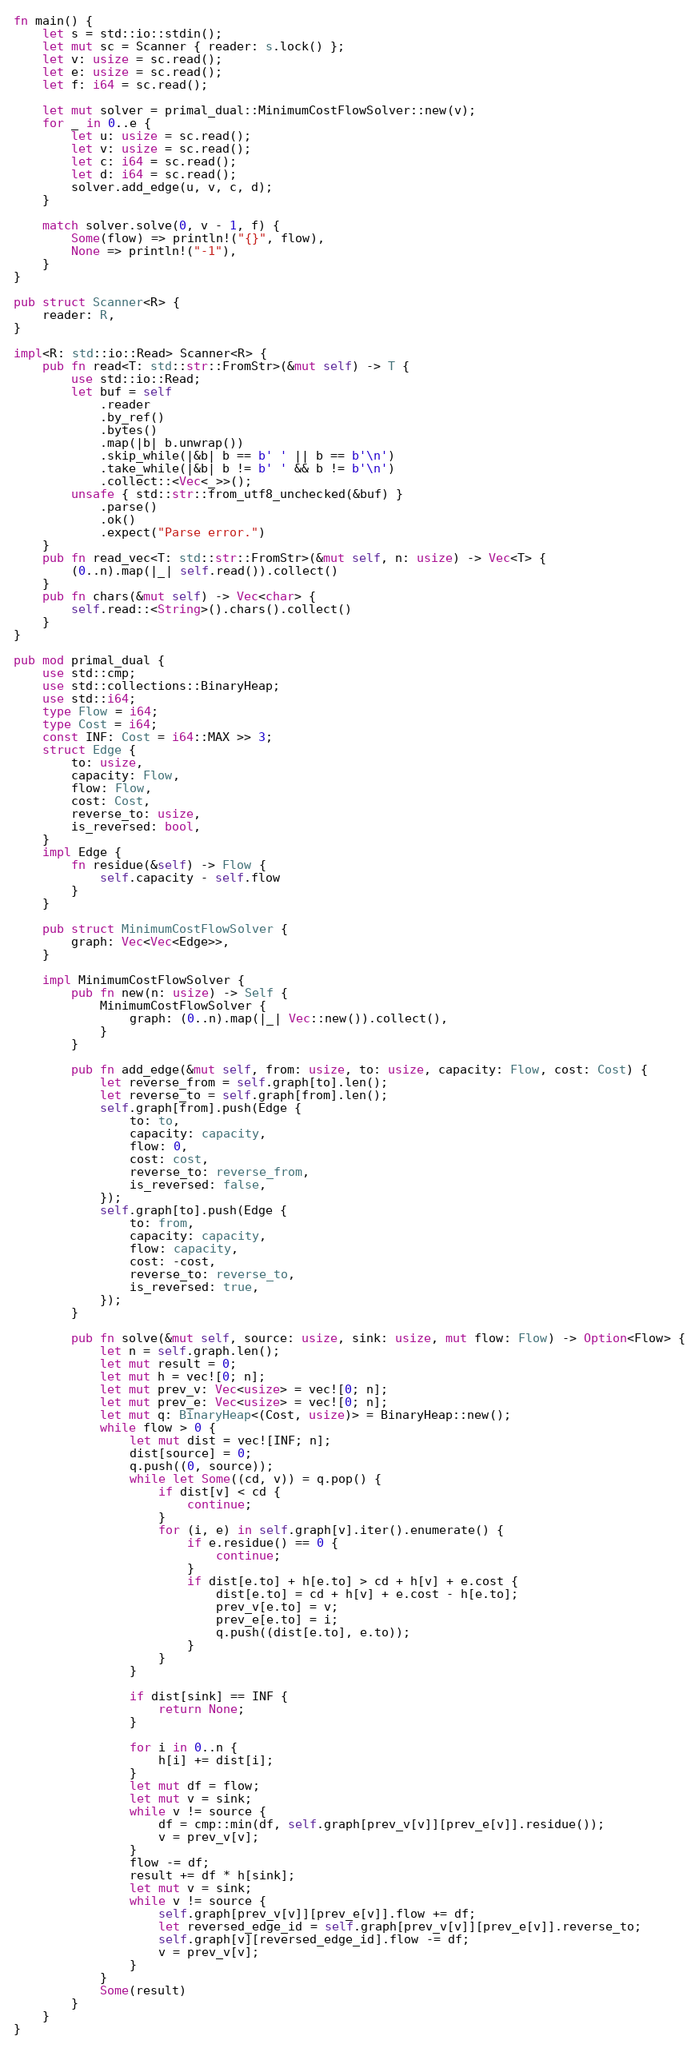<code> <loc_0><loc_0><loc_500><loc_500><_Rust_>fn main() {
    let s = std::io::stdin();
    let mut sc = Scanner { reader: s.lock() };
    let v: usize = sc.read();
    let e: usize = sc.read();
    let f: i64 = sc.read();

    let mut solver = primal_dual::MinimumCostFlowSolver::new(v);
    for _ in 0..e {
        let u: usize = sc.read();
        let v: usize = sc.read();
        let c: i64 = sc.read();
        let d: i64 = sc.read();
        solver.add_edge(u, v, c, d);
    }

    match solver.solve(0, v - 1, f) {
        Some(flow) => println!("{}", flow),
        None => println!("-1"),
    }
}

pub struct Scanner<R> {
    reader: R,
}

impl<R: std::io::Read> Scanner<R> {
    pub fn read<T: std::str::FromStr>(&mut self) -> T {
        use std::io::Read;
        let buf = self
            .reader
            .by_ref()
            .bytes()
            .map(|b| b.unwrap())
            .skip_while(|&b| b == b' ' || b == b'\n')
            .take_while(|&b| b != b' ' && b != b'\n')
            .collect::<Vec<_>>();
        unsafe { std::str::from_utf8_unchecked(&buf) }
            .parse()
            .ok()
            .expect("Parse error.")
    }
    pub fn read_vec<T: std::str::FromStr>(&mut self, n: usize) -> Vec<T> {
        (0..n).map(|_| self.read()).collect()
    }
    pub fn chars(&mut self) -> Vec<char> {
        self.read::<String>().chars().collect()
    }
}

pub mod primal_dual {
    use std::cmp;
    use std::collections::BinaryHeap;
    use std::i64;
    type Flow = i64;
    type Cost = i64;
    const INF: Cost = i64::MAX >> 3;
    struct Edge {
        to: usize,
        capacity: Flow,
        flow: Flow,
        cost: Cost,
        reverse_to: usize,
        is_reversed: bool,
    }
    impl Edge {
        fn residue(&self) -> Flow {
            self.capacity - self.flow
        }
    }

    pub struct MinimumCostFlowSolver {
        graph: Vec<Vec<Edge>>,
    }

    impl MinimumCostFlowSolver {
        pub fn new(n: usize) -> Self {
            MinimumCostFlowSolver {
                graph: (0..n).map(|_| Vec::new()).collect(),
            }
        }

        pub fn add_edge(&mut self, from: usize, to: usize, capacity: Flow, cost: Cost) {
            let reverse_from = self.graph[to].len();
            let reverse_to = self.graph[from].len();
            self.graph[from].push(Edge {
                to: to,
                capacity: capacity,
                flow: 0,
                cost: cost,
                reverse_to: reverse_from,
                is_reversed: false,
            });
            self.graph[to].push(Edge {
                to: from,
                capacity: capacity,
                flow: capacity,
                cost: -cost,
                reverse_to: reverse_to,
                is_reversed: true,
            });
        }

        pub fn solve(&mut self, source: usize, sink: usize, mut flow: Flow) -> Option<Flow> {
            let n = self.graph.len();
            let mut result = 0;
            let mut h = vec![0; n];
            let mut prev_v: Vec<usize> = vec![0; n];
            let mut prev_e: Vec<usize> = vec![0; n];
            let mut q: BinaryHeap<(Cost, usize)> = BinaryHeap::new();
            while flow > 0 {
                let mut dist = vec![INF; n];
                dist[source] = 0;
                q.push((0, source));
                while let Some((cd, v)) = q.pop() {
                    if dist[v] < cd {
                        continue;
                    }
                    for (i, e) in self.graph[v].iter().enumerate() {
                        if e.residue() == 0 {
                            continue;
                        }
                        if dist[e.to] + h[e.to] > cd + h[v] + e.cost {
                            dist[e.to] = cd + h[v] + e.cost - h[e.to];
                            prev_v[e.to] = v;
                            prev_e[e.to] = i;
                            q.push((dist[e.to], e.to));
                        }
                    }
                }

                if dist[sink] == INF {
                    return None;
                }

                for i in 0..n {
                    h[i] += dist[i];
                }
                let mut df = flow;
                let mut v = sink;
                while v != source {
                    df = cmp::min(df, self.graph[prev_v[v]][prev_e[v]].residue());
                    v = prev_v[v];
                }
                flow -= df;
                result += df * h[sink];
                let mut v = sink;
                while v != source {
                    self.graph[prev_v[v]][prev_e[v]].flow += df;
                    let reversed_edge_id = self.graph[prev_v[v]][prev_e[v]].reverse_to;
                    self.graph[v][reversed_edge_id].flow -= df;
                    v = prev_v[v];
                }
            }
            Some(result)
        }
    }
}

</code> 